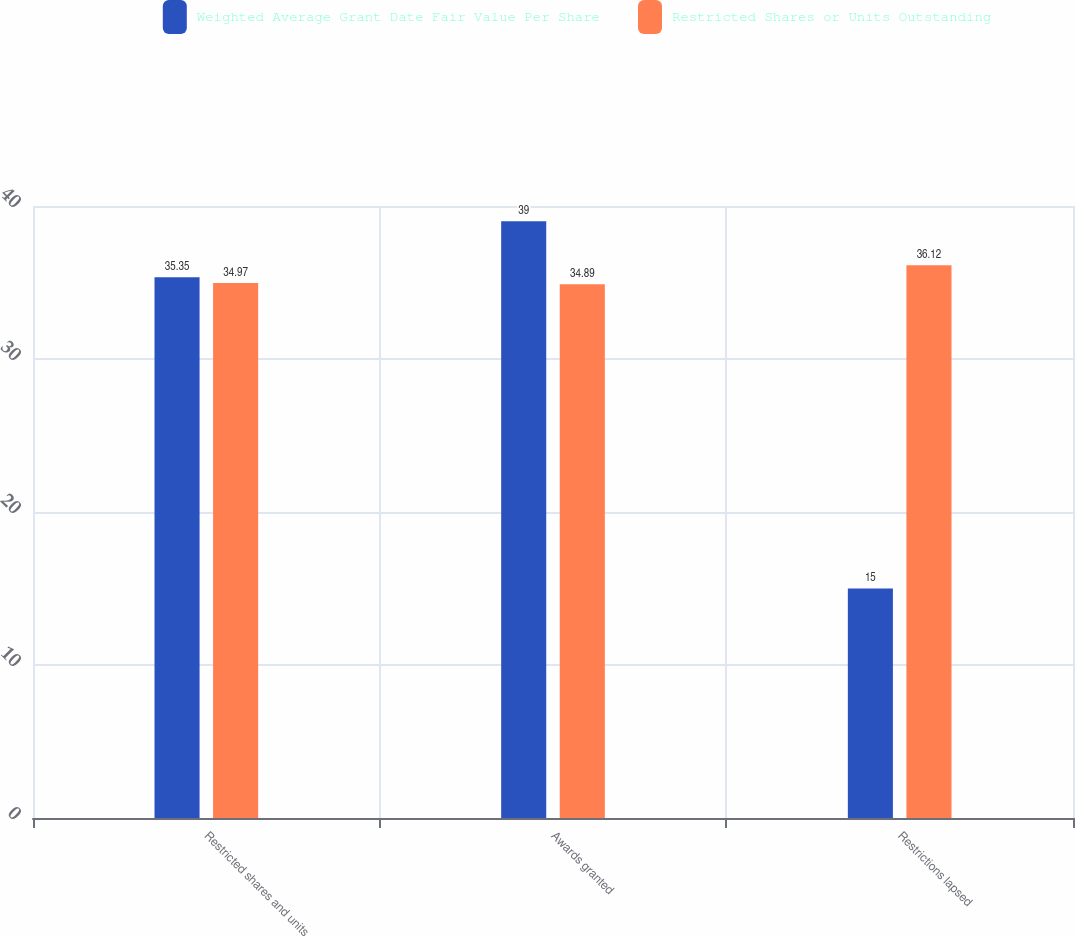Convert chart to OTSL. <chart><loc_0><loc_0><loc_500><loc_500><stacked_bar_chart><ecel><fcel>Restricted shares and units<fcel>Awards granted<fcel>Restrictions lapsed<nl><fcel>Weighted Average Grant Date Fair Value Per Share<fcel>35.35<fcel>39<fcel>15<nl><fcel>Restricted Shares or Units Outstanding<fcel>34.97<fcel>34.89<fcel>36.12<nl></chart> 